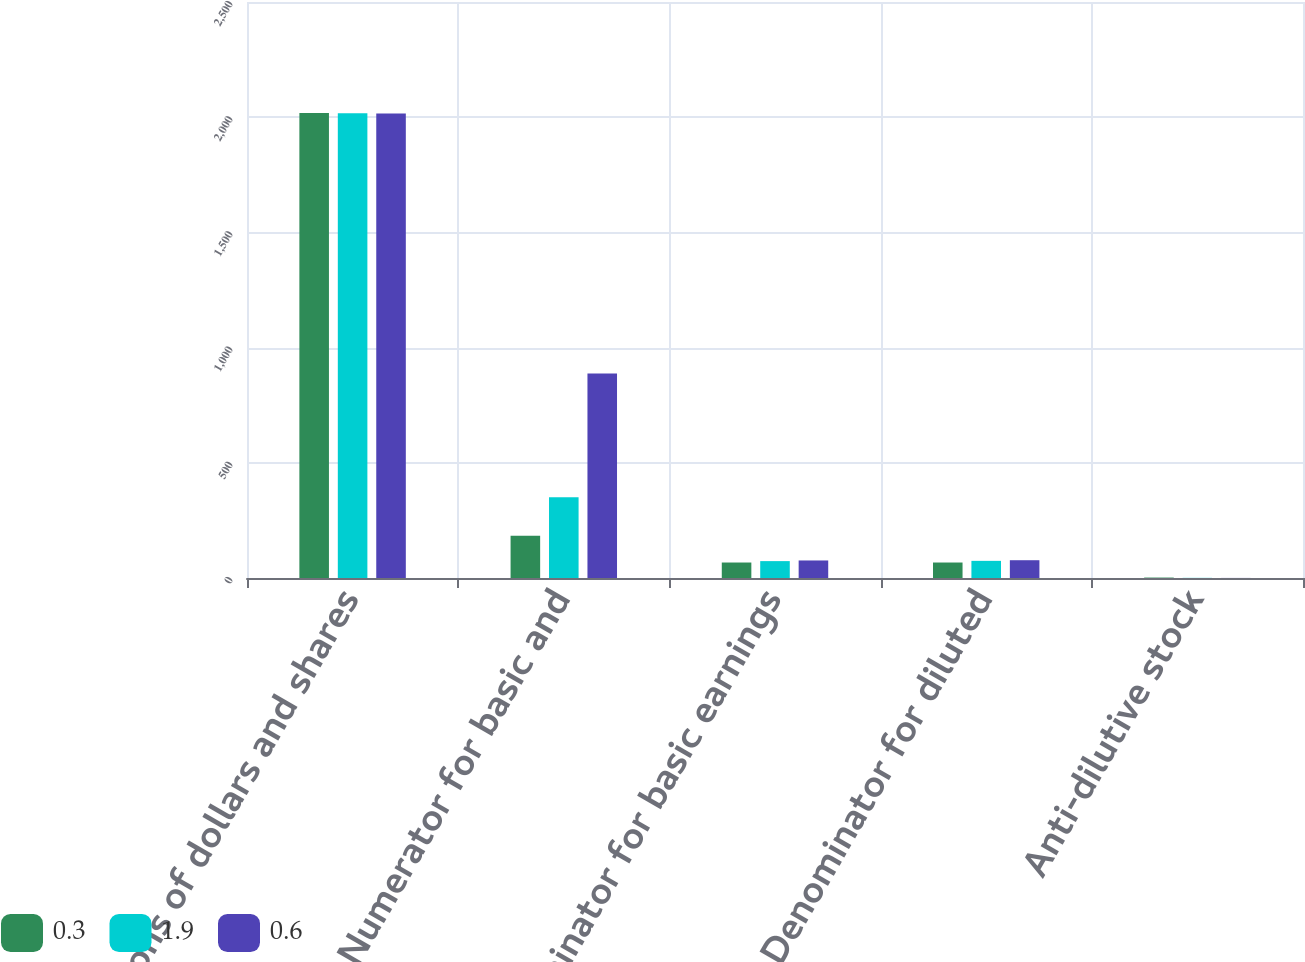<chart> <loc_0><loc_0><loc_500><loc_500><stacked_bar_chart><ecel><fcel>Millions of dollars and shares<fcel>Numerator for basic and<fcel>Denominator for basic earnings<fcel>Denominator for diluted<fcel>Anti-dilutive stock<nl><fcel>0.3<fcel>2018<fcel>183<fcel>67.2<fcel>67.2<fcel>1.9<nl><fcel>1.9<fcel>2017<fcel>350<fcel>73.3<fcel>74.4<fcel>0.6<nl><fcel>0.6<fcel>2016<fcel>888<fcel>76.1<fcel>77.2<fcel>0.3<nl></chart> 